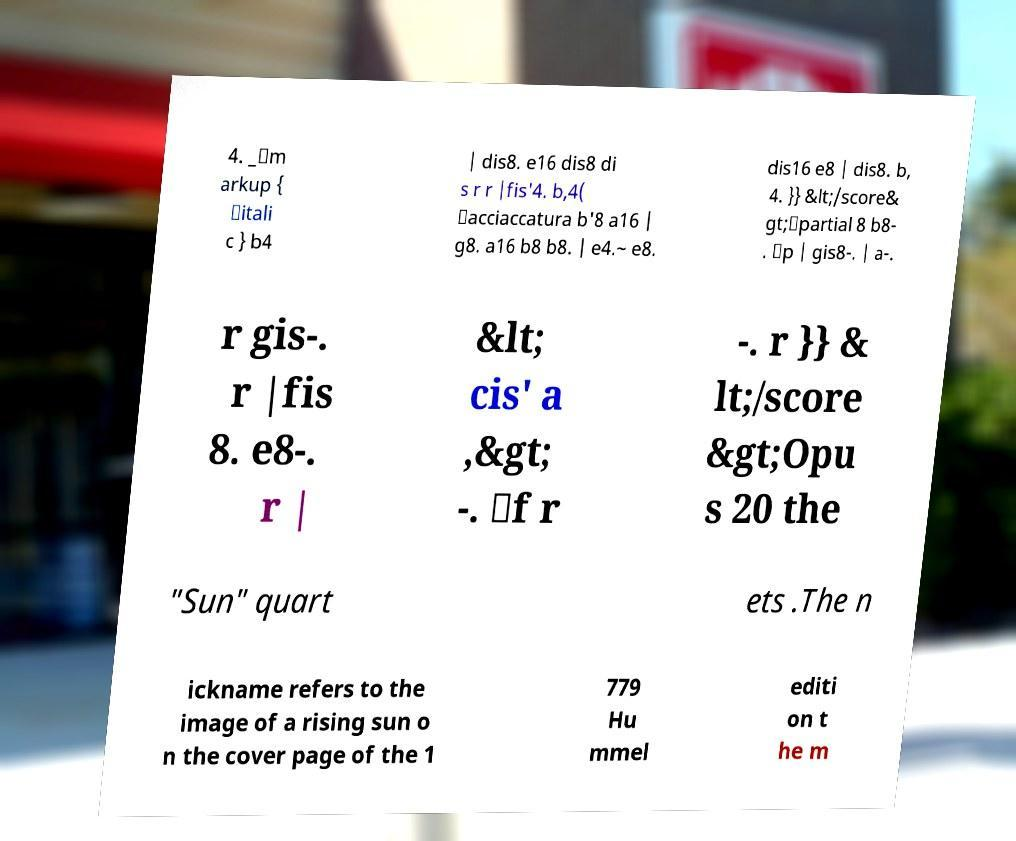Please identify and transcribe the text found in this image. 4. _\m arkup { \itali c } b4 | dis8. e16 dis8 di s r r |fis'4. b,4( \acciaccatura b'8 a16 | g8. a16 b8 b8. | e4.~ e8. dis16 e8 | dis8. b, 4. }} &lt;/score& gt;\partial 8 b8- . \p | gis8-. | a-. r gis-. r |fis 8. e8-. r | &lt; cis' a ,&gt; -. \f r -. r }} & lt;/score &gt;Opu s 20 the "Sun" quart ets .The n ickname refers to the image of a rising sun o n the cover page of the 1 779 Hu mmel editi on t he m 